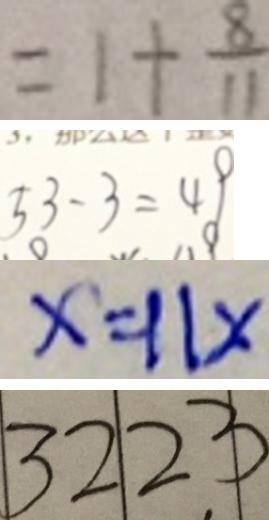<formula> <loc_0><loc_0><loc_500><loc_500>= 1 + \frac { 8 } { 1 1 } 
 5 3 - 3 = 4 9 
 x = 1 1 x 
 3 2 2 3</formula> 